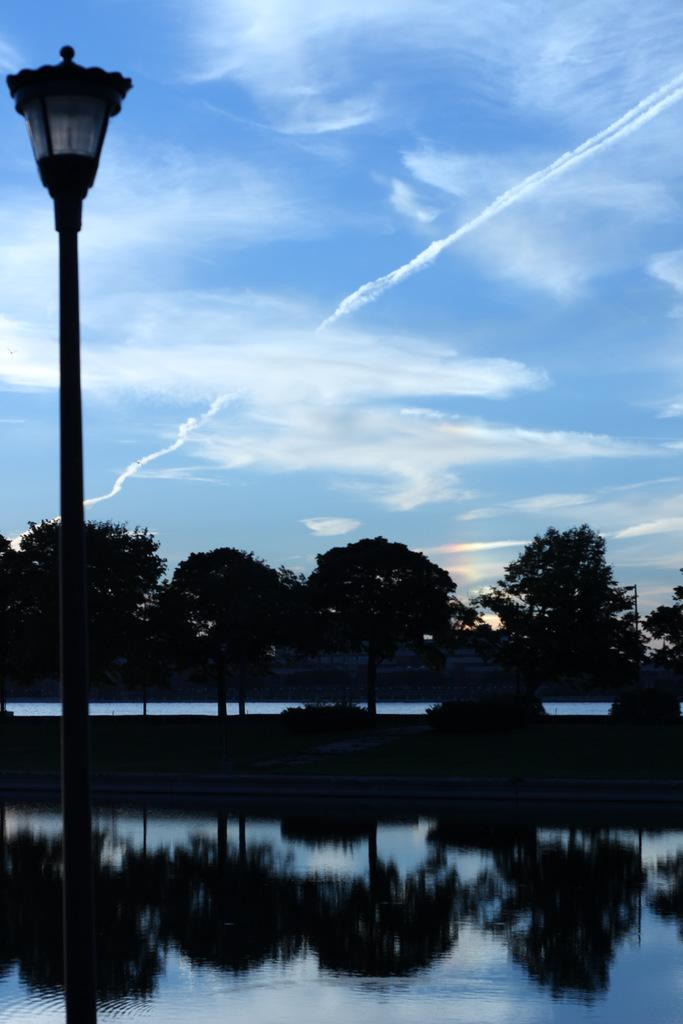What is located in the center of the image? There is water, a pole, and trees in the center of the image. What can be seen in the background of the image? The sky is visible in the background of the image, and clouds are present. What type of vegetable is growing on the pole in the image? There are no vegetables present in the image, and the pole is not a support for vegetation. 